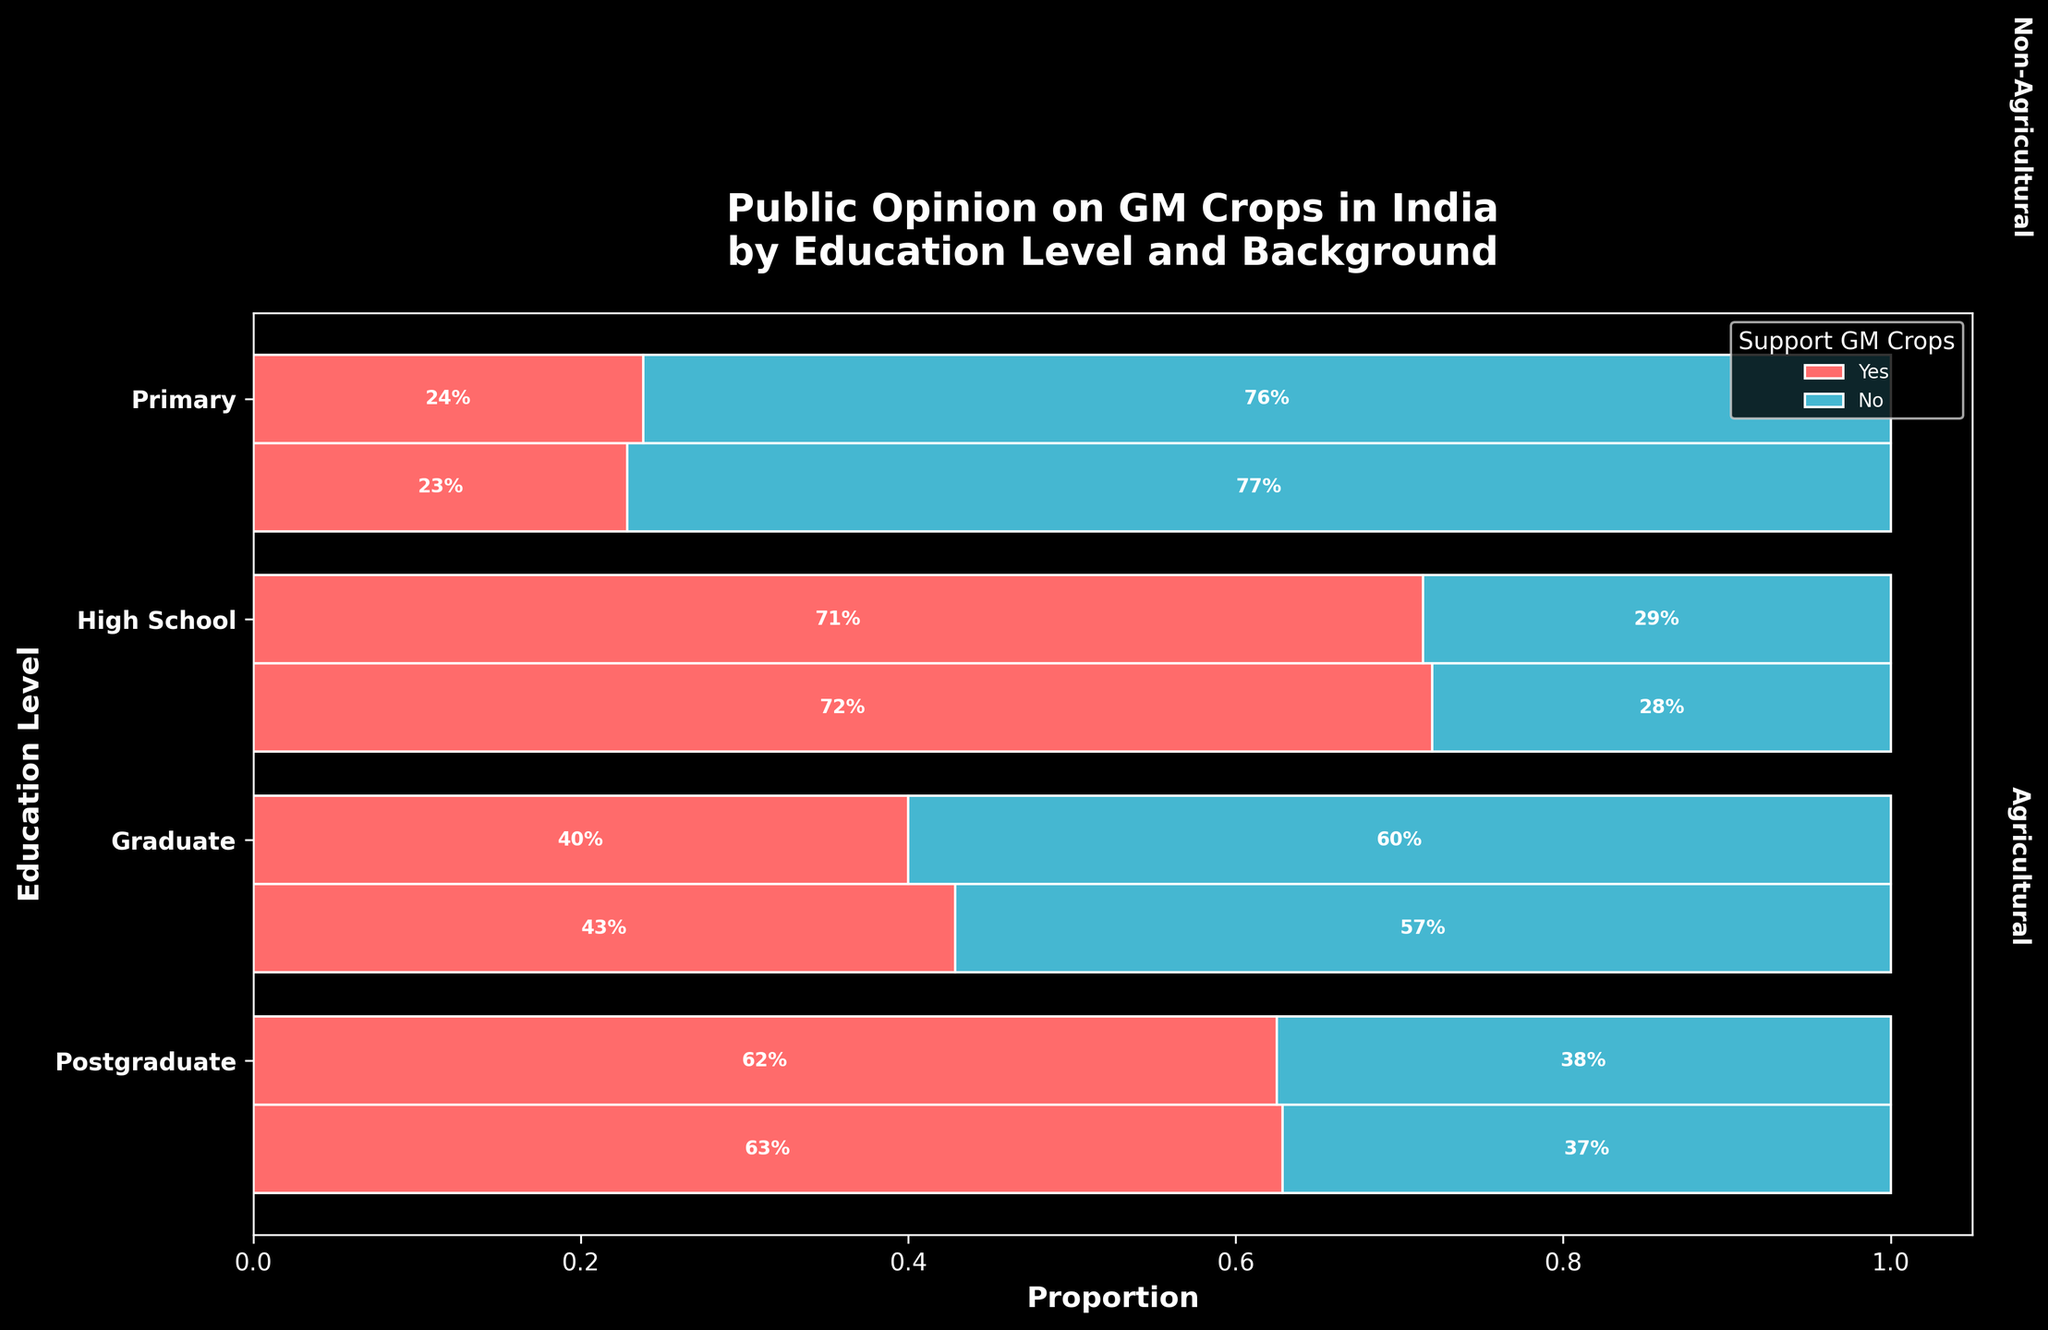What is the title of the plot? The title is typically located at the top of the plot, and it serves to summarize the main topic of the plot. In this case, it states "Public Opinion on GM Crops in India by Education Level and Background".
Answer: Public Opinion on GM Crops in India by Education Level and Background What does the x-axis represent in the plot? The x-axis represents the proportion of responses, demonstrating support for or against GM crops. This information is inferred from the axis label and the scale indicators.
Answer: Proportion Which education level shows the highest proportion of support for GM crops among those with an agricultural background? To answer this, look for the segment with the largest horizontal width labeled 'Yes' within each education level for the agricultural background. In this case, 'Graduate' with agricultural background has the highest proportion.
Answer: Graduate Compare the proportion of support for GM crops between postgraduate and high school levels for non-agricultural backgrounds. Observe the width of the 'Yes' segments for both 'Postgraduate' and 'High School' under the non-agricultural background. Postgraduates have a proportionally wider 'Yes' segment than High School.
Answer: Postgraduate > High School What percentage of primary education level respondents with an agricultural background support GM crops? Locate the 'Primary' education level segment for 'Agricultural' background and identify the 'Yes' segment. The percentage label in this segment indicates support.
Answer: 23% How does the support for GM crops differ between agricultural and non-agricultural backgrounds within the graduate education level? Compare the width of the 'Yes' segments for both backgrounds under the graduate education level. Agricultural has a 63% support, compared to 62% in non-agricultural.
Answer: Very similar with agricultural slightly higher Which background, agricultural or non-agricultural, shows higher opposition to GM crops in the primary education level? Examine the 'No' segments in the primary education level for both backgrounds. Non-agricultural (76%) has a higher proportion of opposition compared to agricultural (77%).
Answer: Non-agricultural Is the overall trend in support for GM crops higher with increasing education levels? Compare the proportion of 'Yes' segments as education level increases. Generally, higher education levels show higher support percentages for GM crops.
Answer: Yes Which education level has the highest proportion of opposition to GM crops in any background? Identify the segment with the largest 'No' proportion across all education levels and backgrounds. For primary education with a non-agricultural background (76%) shows the highest opposition.
Answer: Primary Non-Agricultural What is the proportion of support for GM crops among overall postgraduate respondents? Calculate the combined widths of the 'Yes' segments from both backgrounds for the postgraduate level. It's 250 + 180 = 430 respondents out of 600 total, which proportionally aligns.
Answer: 71.7% 